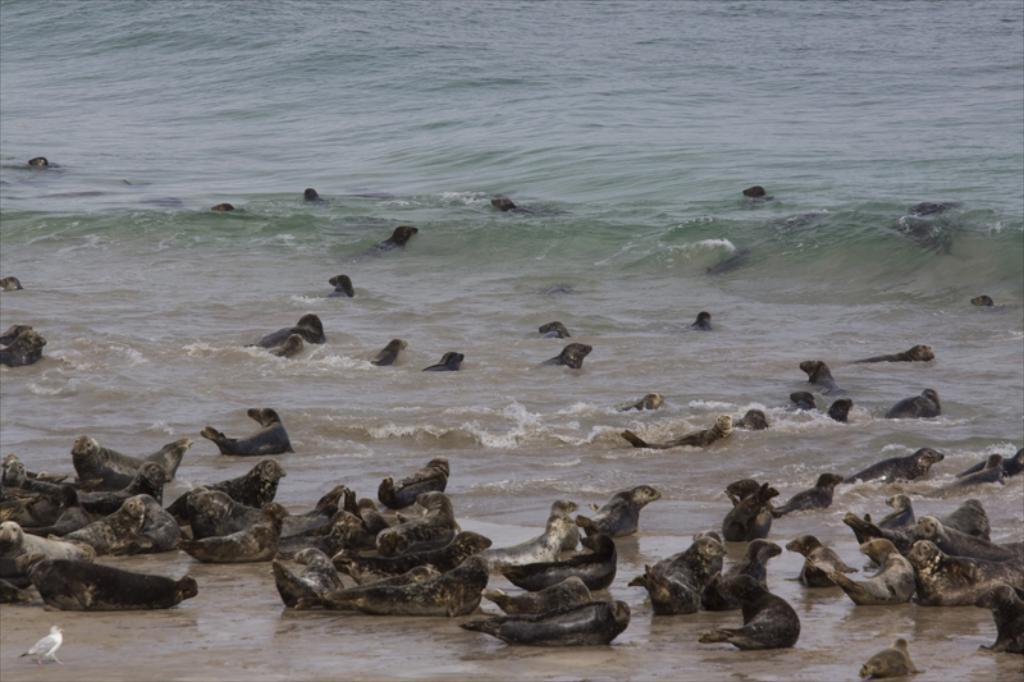Where was the image taken? The image was taken on a sea beach. What can be seen in the center of the image? There are seals in the center of the image. What other animal is present in the image? There is a bird in the front on the left side of the image. What is the color of the bird? The bird is white in color. Can you tell me how many donkeys are grazing on the wall in the image? There are no donkeys or walls present in the image; it features seals and a bird on a sea beach. 